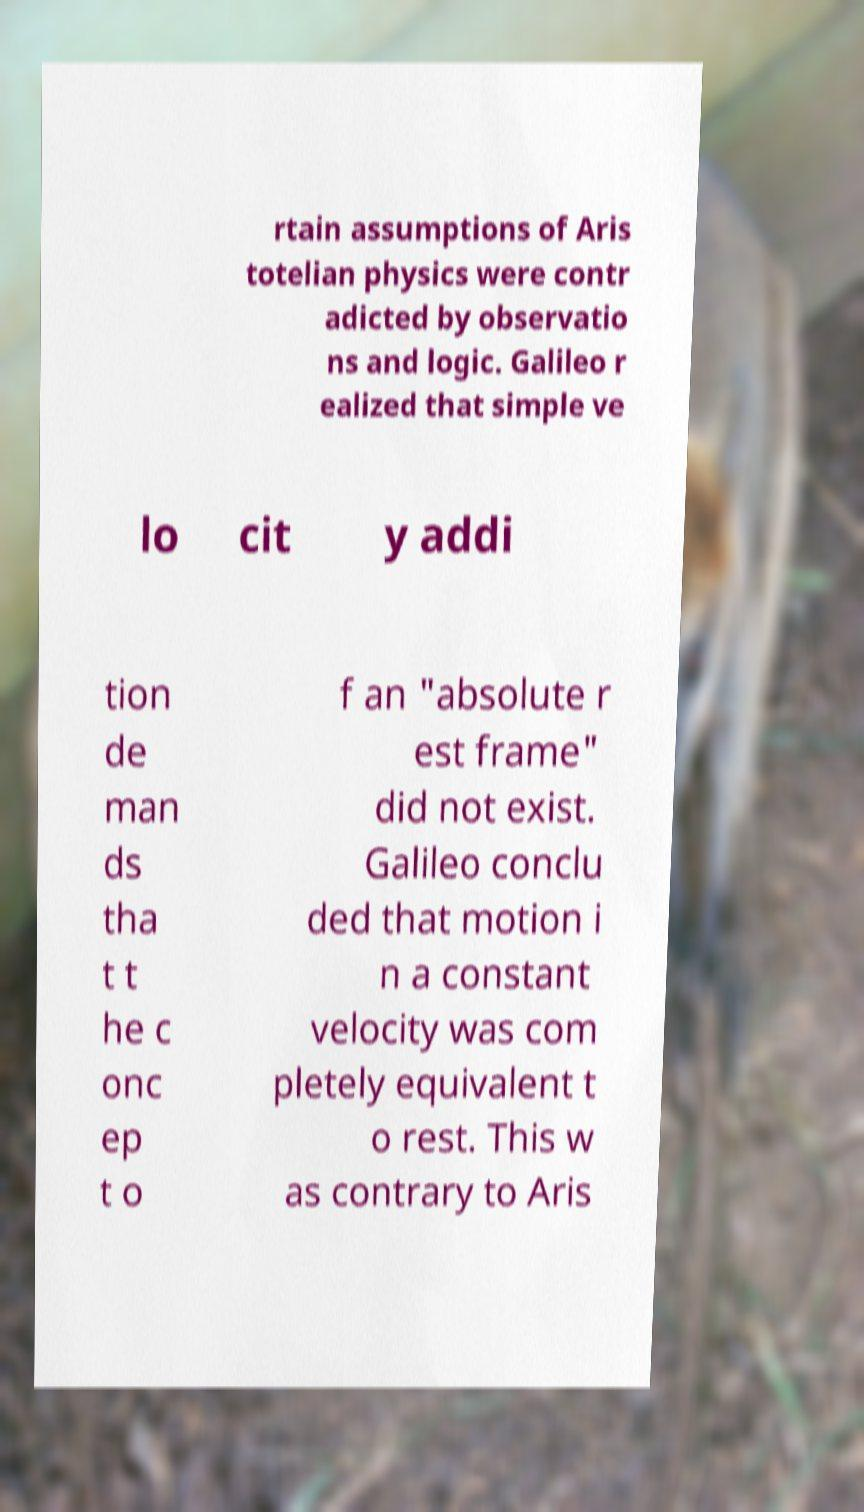Please identify and transcribe the text found in this image. rtain assumptions of Aris totelian physics were contr adicted by observatio ns and logic. Galileo r ealized that simple ve lo cit y addi tion de man ds tha t t he c onc ep t o f an "absolute r est frame" did not exist. Galileo conclu ded that motion i n a constant velocity was com pletely equivalent t o rest. This w as contrary to Aris 